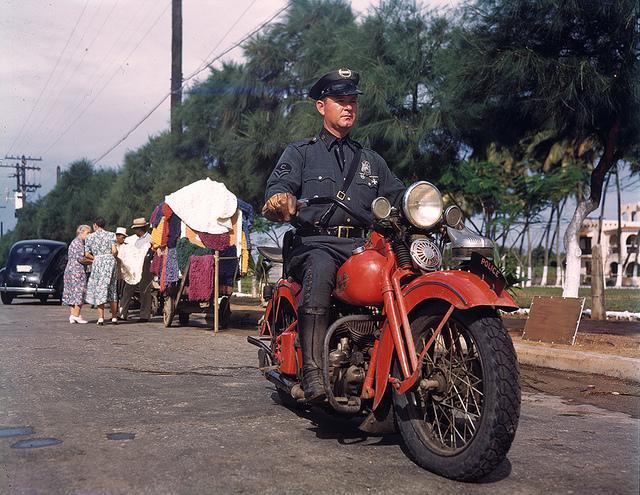How many people are there?
Give a very brief answer. 3. How many woman are holding a donut with one hand?
Give a very brief answer. 0. 